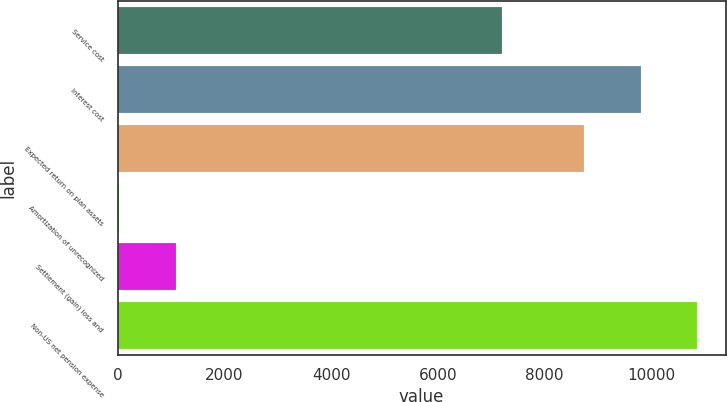Convert chart. <chart><loc_0><loc_0><loc_500><loc_500><bar_chart><fcel>Service cost<fcel>Interest cost<fcel>Expected return on plan assets<fcel>Amortization of unrecognized<fcel>Settlement (gain) loss and<fcel>Non-US net pension expense<nl><fcel>7208<fcel>9800.6<fcel>8747<fcel>33<fcel>1086.6<fcel>10854.2<nl></chart> 